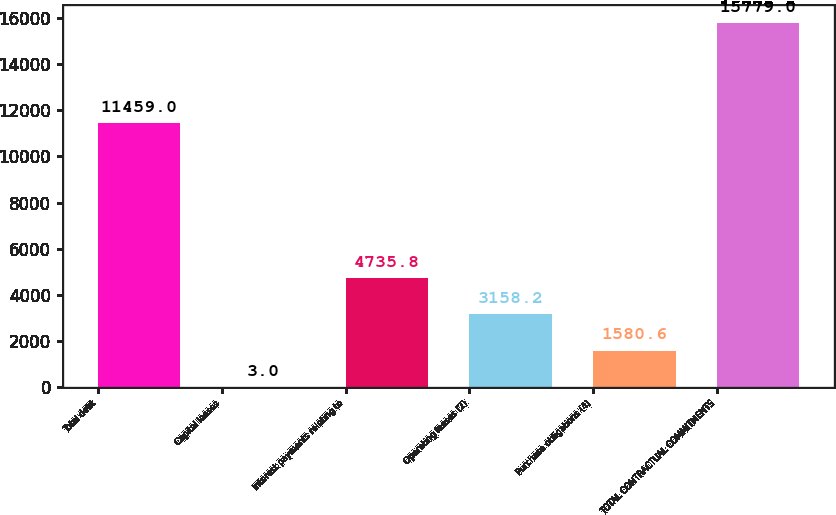<chart> <loc_0><loc_0><loc_500><loc_500><bar_chart><fcel>Total debt<fcel>Capital leases<fcel>Interest payments relating to<fcel>Operating leases (2)<fcel>Purchase obligations (4)<fcel>TOTAL CONTRACTUAL COMMITMENTS<nl><fcel>11459<fcel>3<fcel>4735.8<fcel>3158.2<fcel>1580.6<fcel>15779<nl></chart> 